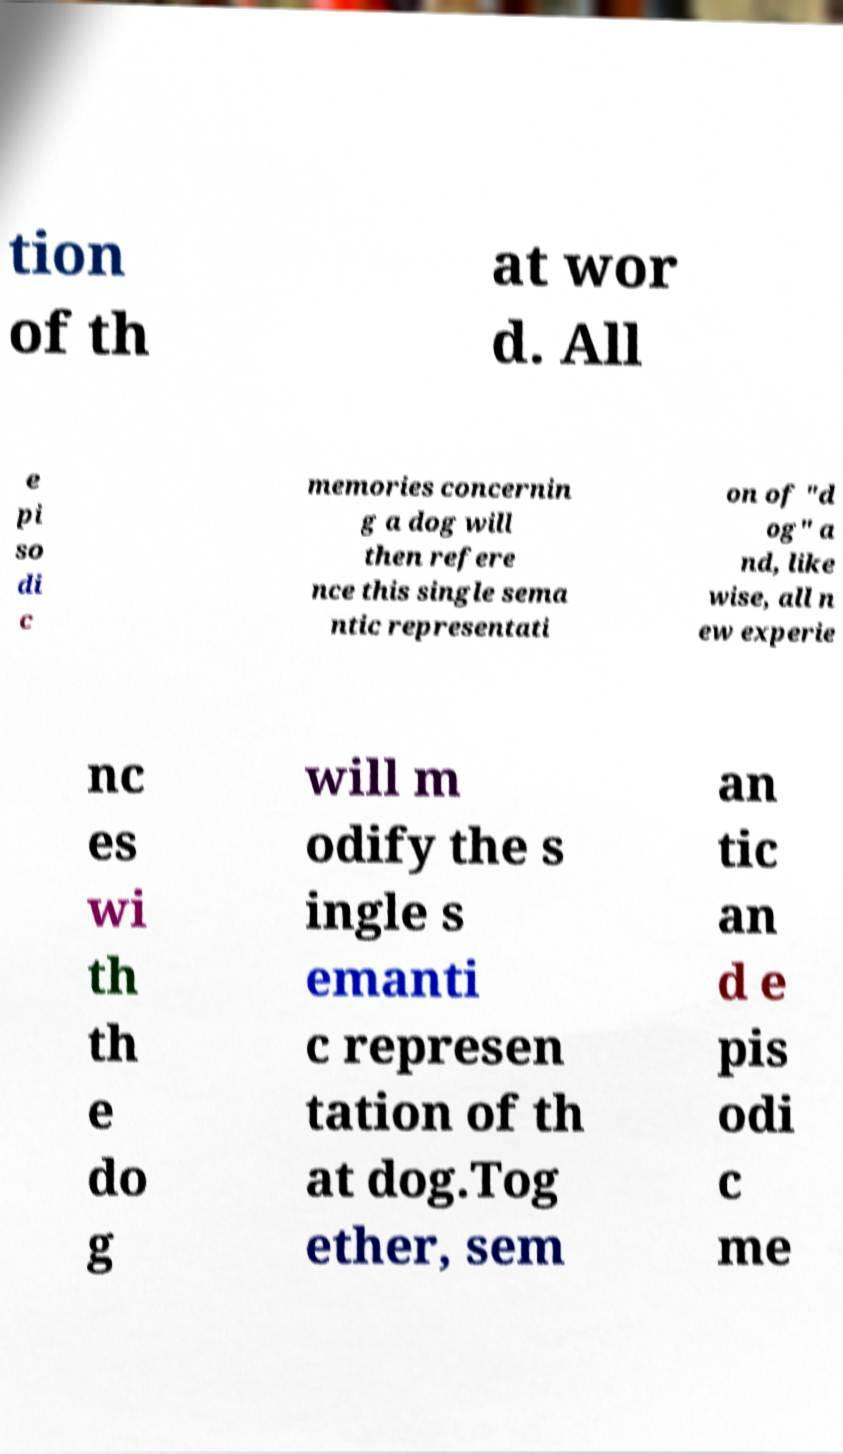I need the written content from this picture converted into text. Can you do that? tion of th at wor d. All e pi so di c memories concernin g a dog will then refere nce this single sema ntic representati on of "d og" a nd, like wise, all n ew experie nc es wi th th e do g will m odify the s ingle s emanti c represen tation of th at dog.Tog ether, sem an tic an d e pis odi c me 